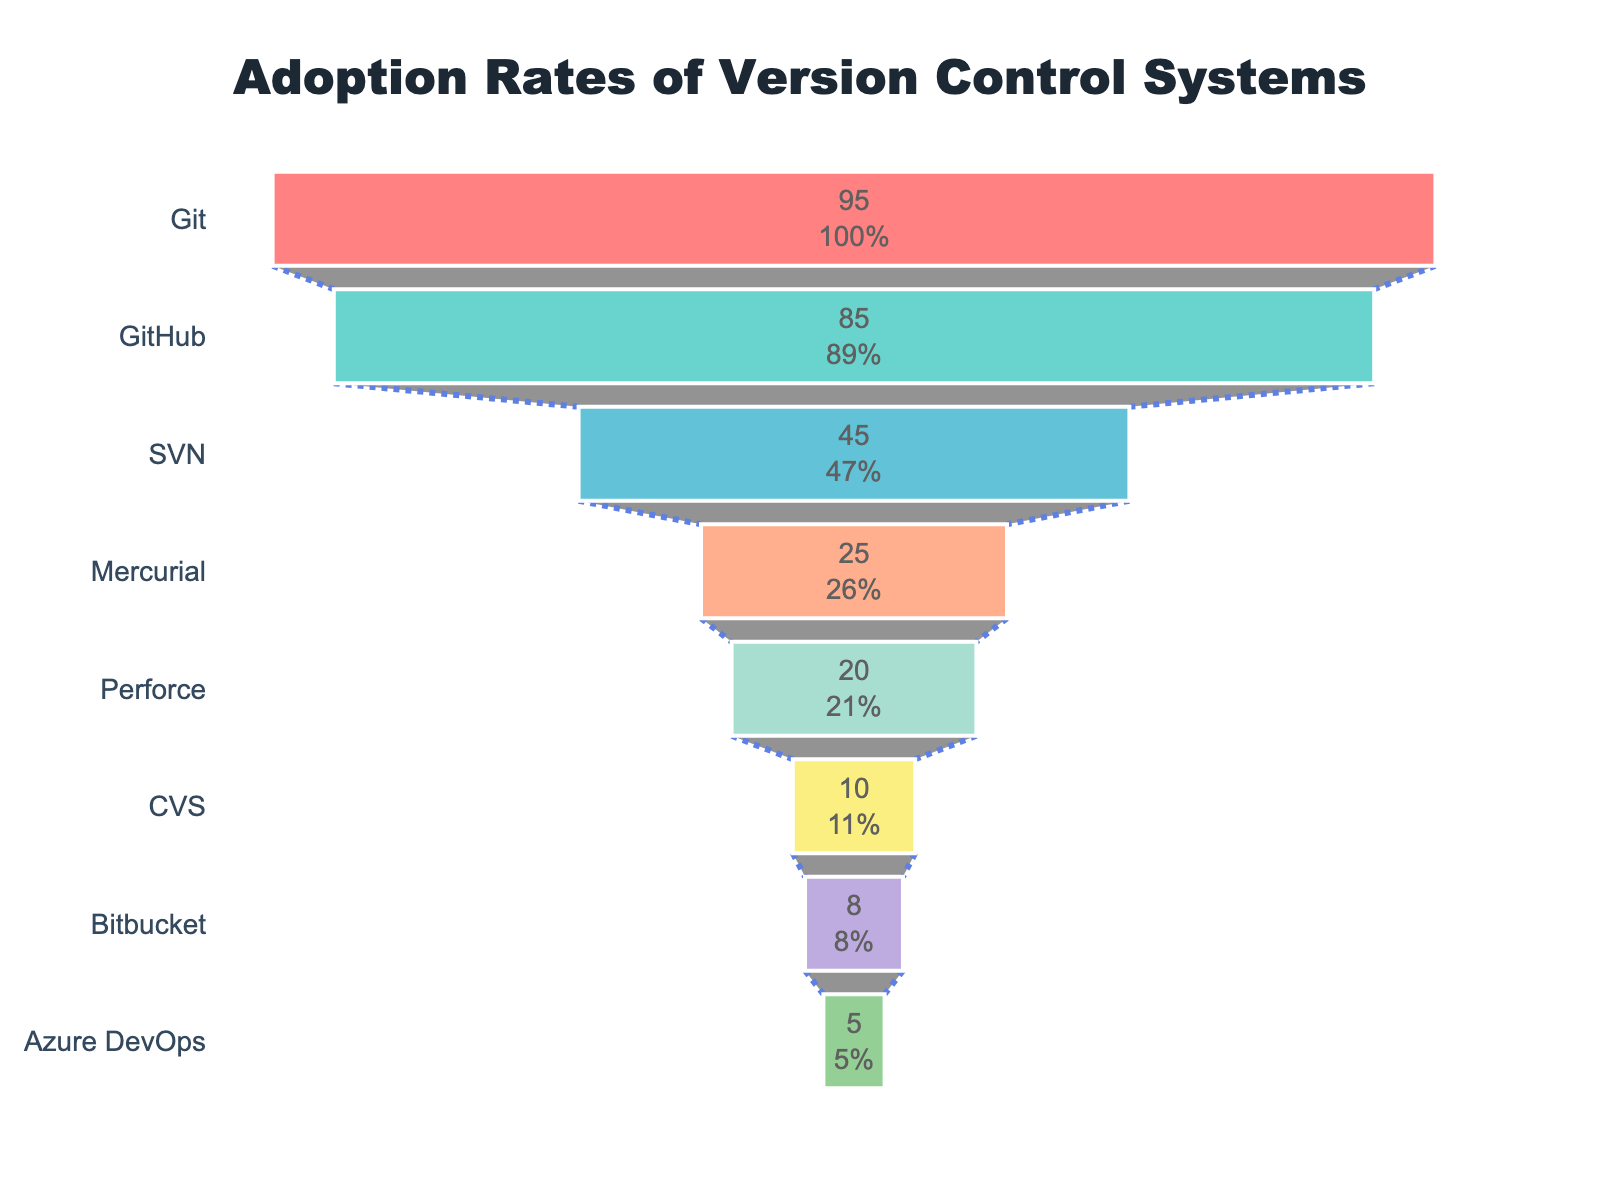Which version control system has the highest adoption rate? The funnel chart shows that Git has the highest percentage at the top, indicating the most popular version control system among developers.
Answer: Git What is the adoption rate of Mercurial? The chart displays percentages for each version control system, and Mercurial has a percentage of 25.
Answer: 25% How does the adoption rate of SVN compare to Perforce? By examining the chart, SVN has an adoption rate of 45, whereas Perforce has an adoption rate of 20. 45 is more than 20.
Answer: SVN's rate is higher How many version control systems have an adoption rate above 50%? The chart lists Git, GitHub, and SVN with percentages above 50%. Counting these, we find that there are three such systems.
Answer: 3 What is the combined adoption rate of Git and GitHub? Git has an adoption rate of 95, and GitHub has 85. Adding these two values results in 95 + 85 = 180.
Answer: 180% Explain the trend of adoption rates as you move down the chart. The funnel chart visually narrows as you move from top to bottom, with the percentages decreasing at each level (starting from 95% at Git to 5% at Azure DevOps), indicating a decrease in adoption rates for less popular systems.
Answer: Decreasing trend Which version control system has the lowest adoption rate, and what is it? Looking at the bottom of the funnel chart, Azure DevOps has the lowest adoption rate of 5%.
Answer: Azure DevOps, 5% Calculate the average adoption rate of the top three version control systems. The top three systems are Git (95%), GitHub (85%), and SVN (45%). Adding these, 95 + 85 + 45 = 225. Dividing by three, the average is 225 / 3 = 75.
Answer: 75% Order the version control systems with adoption rates below 30% from highest to lowest. From the chart, systems below 30% are Mercurial (25%), Perforce (20%), CVS (10%), Bitbucket (8%), and Azure DevOps (5%). Ordering them from highest to lowest: Mercurial, Perforce, CVS, Bitbucket, Azure DevOps.
Answer: Mercurial, Perforce, CVS, Bitbucket, Azure DevOps What is the difference in adoption rate between the most popular and the least popular version control system? Git has the highest adoption rate at 95%, and Azure DevOps has the lowest at 5%. The difference is calculated as 95 - 5 = 90.
Answer: 90% 